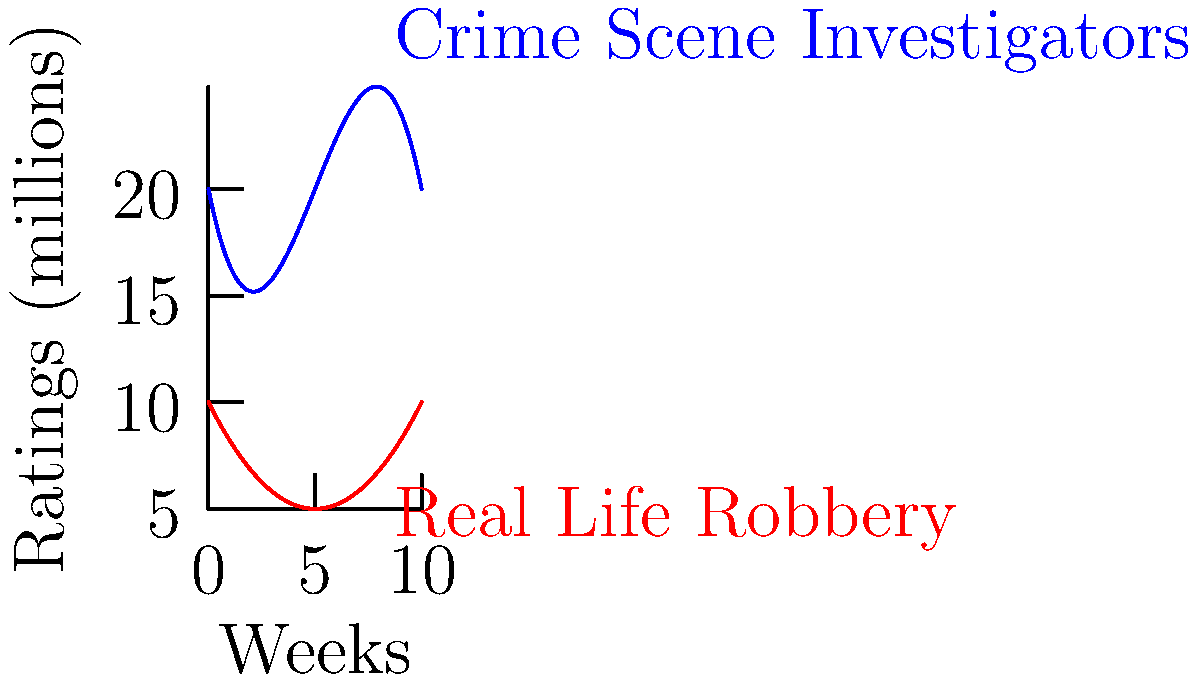As a reality show producer, you're analyzing the ratings of two competing crime shows: "Crime Scene Investigators" and "Real Life Robbery". The graph shows their ratings (in millions of viewers) over 10 weeks. The blue curve represents "Crime Scene Investigators" with the function $f(x) = -0.1x^3 + 1.5x^2 - 5x + 20$, while the red curve represents "Real Life Robbery" with the function $g(x) = 0.2x^2 - 2x + 10$, where $x$ is the number of weeks since the shows' premieres. At which week do the ratings of these two shows intersect, and what is the corresponding rating at this intersection point? To find the intersection point, we need to solve the equation:

$f(x) = g(x)$

$-0.1x^3 + 1.5x^2 - 5x + 20 = 0.2x^2 - 2x + 10$

Rearranging the terms:

$-0.1x^3 + 1.3x^2 - 3x + 10 = 0$

This is a cubic equation. We can solve it using a graphing calculator or computer algebra system. The solutions are approximately:

$x \approx 1.37, 5.76, 10.87$

Since we're only interested in the first 10 weeks, we can discard the third solution. The first solution ($x \approx 1.37$) represents the initial intersection, and the second solution ($x \approx 5.76$) is the one we're looking for.

To find the rating at this point, we can substitute $x = 5.76$ into either function:

$f(5.76) \approx g(5.76) \approx 13.95$

Therefore, the shows intersect at approximately 5.76 weeks, with a rating of about 13.95 million viewers.
Answer: Week 5.76, 13.95 million viewers 